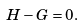Convert formula to latex. <formula><loc_0><loc_0><loc_500><loc_500>H - G = 0 .</formula> 